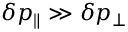<formula> <loc_0><loc_0><loc_500><loc_500>\delta p _ { \| } \gg \delta p _ { \perp }</formula> 